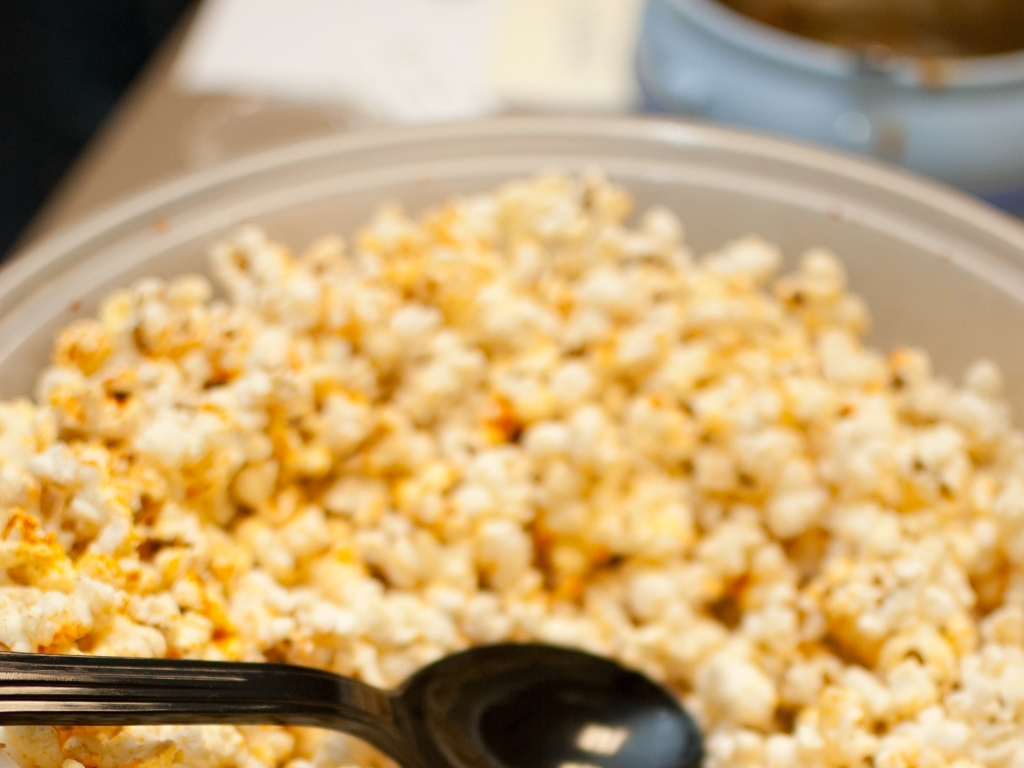Are the details of the rice clear? The details of the rice are somewhat distinguishable. Although the image is focused, it's not sharp enough to clearly see each grain of rice. The overall texture and color can be made out, indicating it's cooked rice, possibly seasoned with spices given its non-uniform coloration. 